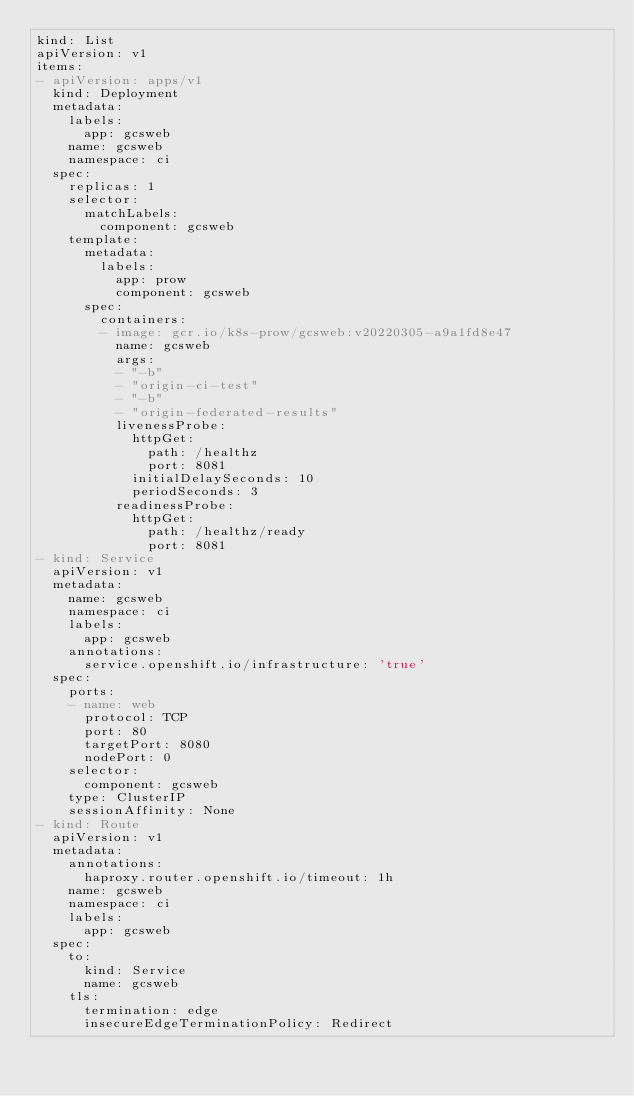<code> <loc_0><loc_0><loc_500><loc_500><_YAML_>kind: List
apiVersion: v1
items:
- apiVersion: apps/v1
  kind: Deployment
  metadata:
    labels:
      app: gcsweb
    name: gcsweb
    namespace: ci
  spec:
    replicas: 1
    selector:
      matchLabels:
        component: gcsweb
    template:
      metadata:
        labels:
          app: prow
          component: gcsweb
      spec:
        containers:
        - image: gcr.io/k8s-prow/gcsweb:v20220305-a9a1fd8e47
          name: gcsweb
          args:
          - "-b"
          - "origin-ci-test"
          - "-b"
          - "origin-federated-results"
          livenessProbe:
            httpGet:
              path: /healthz
              port: 8081
            initialDelaySeconds: 10
            periodSeconds: 3
          readinessProbe:
            httpGet:
              path: /healthz/ready
              port: 8081
- kind: Service
  apiVersion: v1
  metadata:
    name: gcsweb
    namespace: ci
    labels:
      app: gcsweb
    annotations:
      service.openshift.io/infrastructure: 'true'
  spec:
    ports:
    - name: web
      protocol: TCP
      port: 80
      targetPort: 8080
      nodePort: 0
    selector:
      component: gcsweb
    type: ClusterIP
    sessionAffinity: None
- kind: Route
  apiVersion: v1
  metadata:
    annotations:
      haproxy.router.openshift.io/timeout: 1h
    name: gcsweb
    namespace: ci
    labels:
      app: gcsweb
  spec:
    to:
      kind: Service
      name: gcsweb
    tls:
      termination: edge
      insecureEdgeTerminationPolicy: Redirect
</code> 